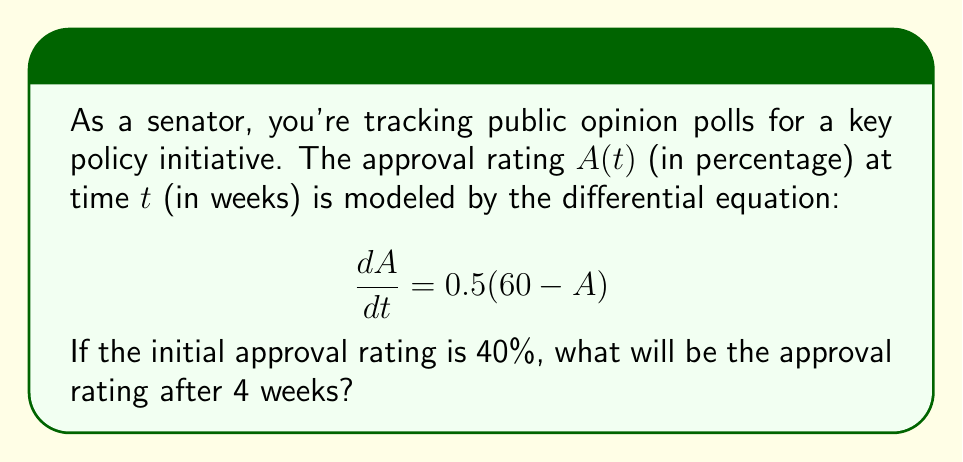Give your solution to this math problem. Let's solve this step-by-step:

1) We have a first-order linear differential equation:
   $$\frac{dA}{dt} = 0.5(60 - A)$$

2) This is in the form $\frac{dA}{dt} + PA = Q$, where $P = 0.5$ and $Q = 30$.

3) The general solution for this type of equation is:
   $$A(t) = e^{-\int P dt}(\int Qe^{\int P dt}dt + C)$$

4) Solving $\int P dt$:
   $$\int 0.5 dt = 0.5t$$

5) Substituting into the general solution:
   $$A(t) = e^{-0.5t}(\int 30e^{0.5t}dt + C)$$

6) Solving the integral:
   $$A(t) = e^{-0.5t}(60e^{0.5t} + C) = 60 + Ce^{-0.5t}$$

7) Using the initial condition $A(0) = 40$:
   $$40 = 60 + C$$
   $$C = -20$$

8) Therefore, the particular solution is:
   $$A(t) = 60 - 20e^{-0.5t}$$

9) To find $A(4)$, we substitute $t = 4$:
   $$A(4) = 60 - 20e^{-0.5(4)} = 60 - 20e^{-2} \approx 55.73$$
Answer: 55.73% 